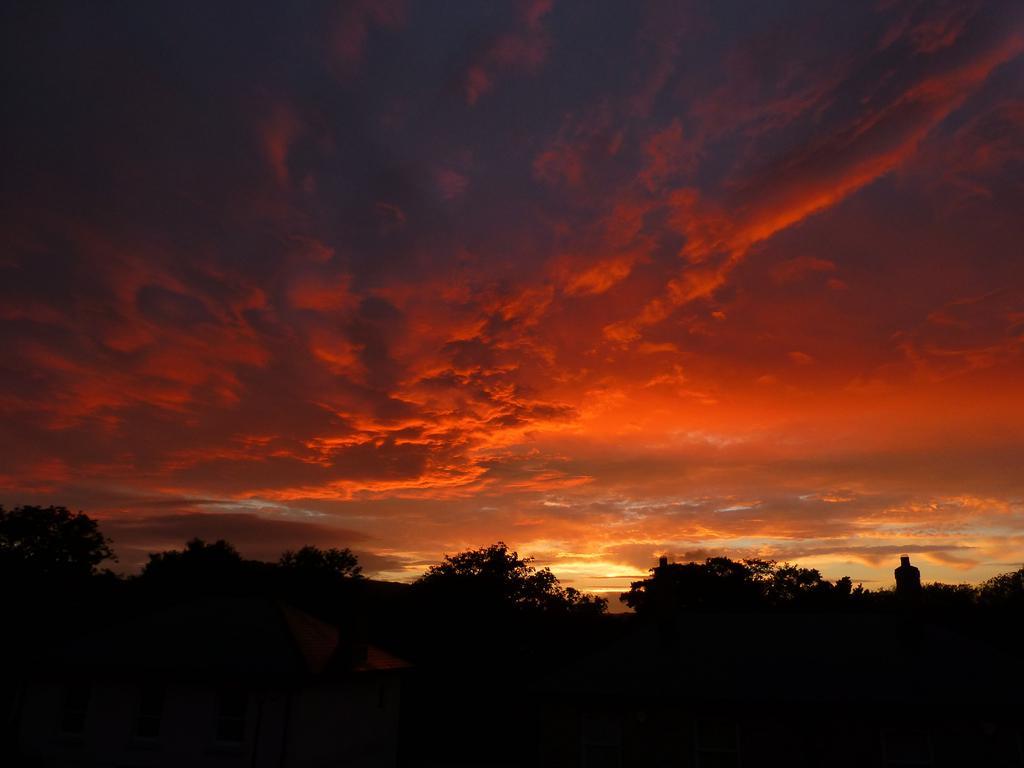Could you give a brief overview of what you see in this image? In the center of the image we can see the sky, clouds, trees, one house and a few other objects. 